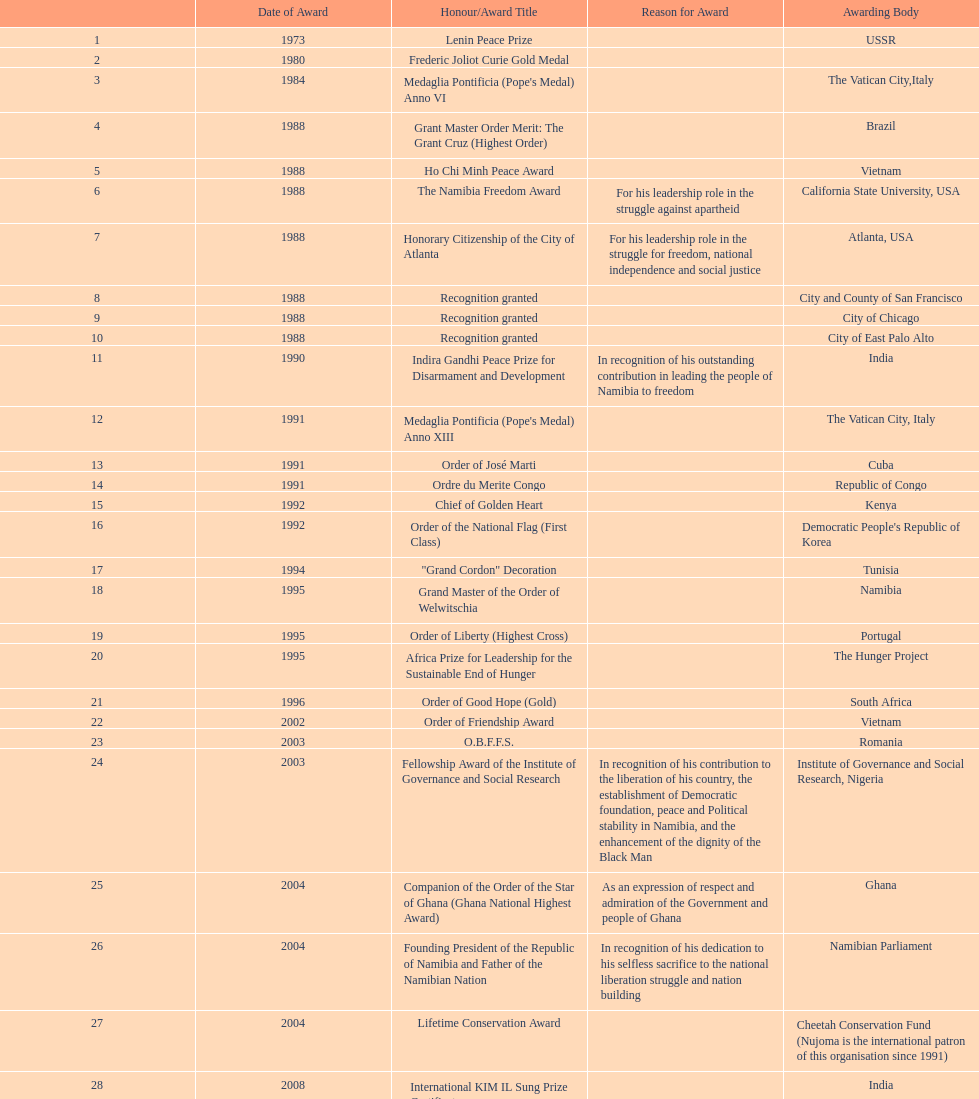What was the overall count of honors/award titles mentioned in this chart? 29. 